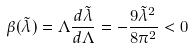Convert formula to latex. <formula><loc_0><loc_0><loc_500><loc_500>\beta ( \tilde { \lambda } ) = \Lambda \frac { d \tilde { \lambda } } { d \Lambda } = - \frac { 9 \tilde { \lambda } ^ { 2 } } { 8 \pi ^ { 2 } } < 0</formula> 